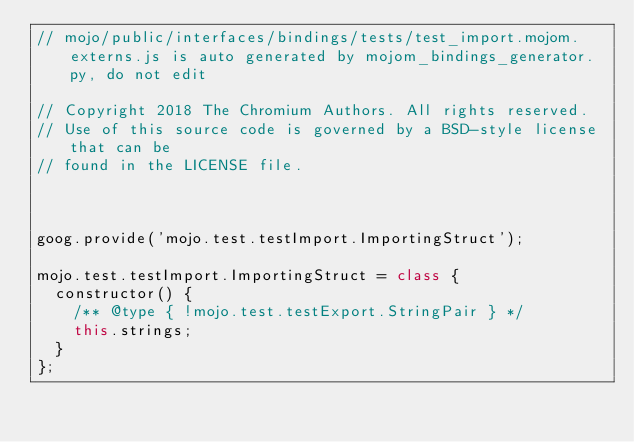<code> <loc_0><loc_0><loc_500><loc_500><_JavaScript_>// mojo/public/interfaces/bindings/tests/test_import.mojom.externs.js is auto generated by mojom_bindings_generator.py, do not edit

// Copyright 2018 The Chromium Authors. All rights reserved.
// Use of this source code is governed by a BSD-style license that can be
// found in the LICENSE file.



goog.provide('mojo.test.testImport.ImportingStruct');

mojo.test.testImport.ImportingStruct = class {
  constructor() {
    /** @type { !mojo.test.testExport.StringPair } */
    this.strings;
  }
};
</code> 